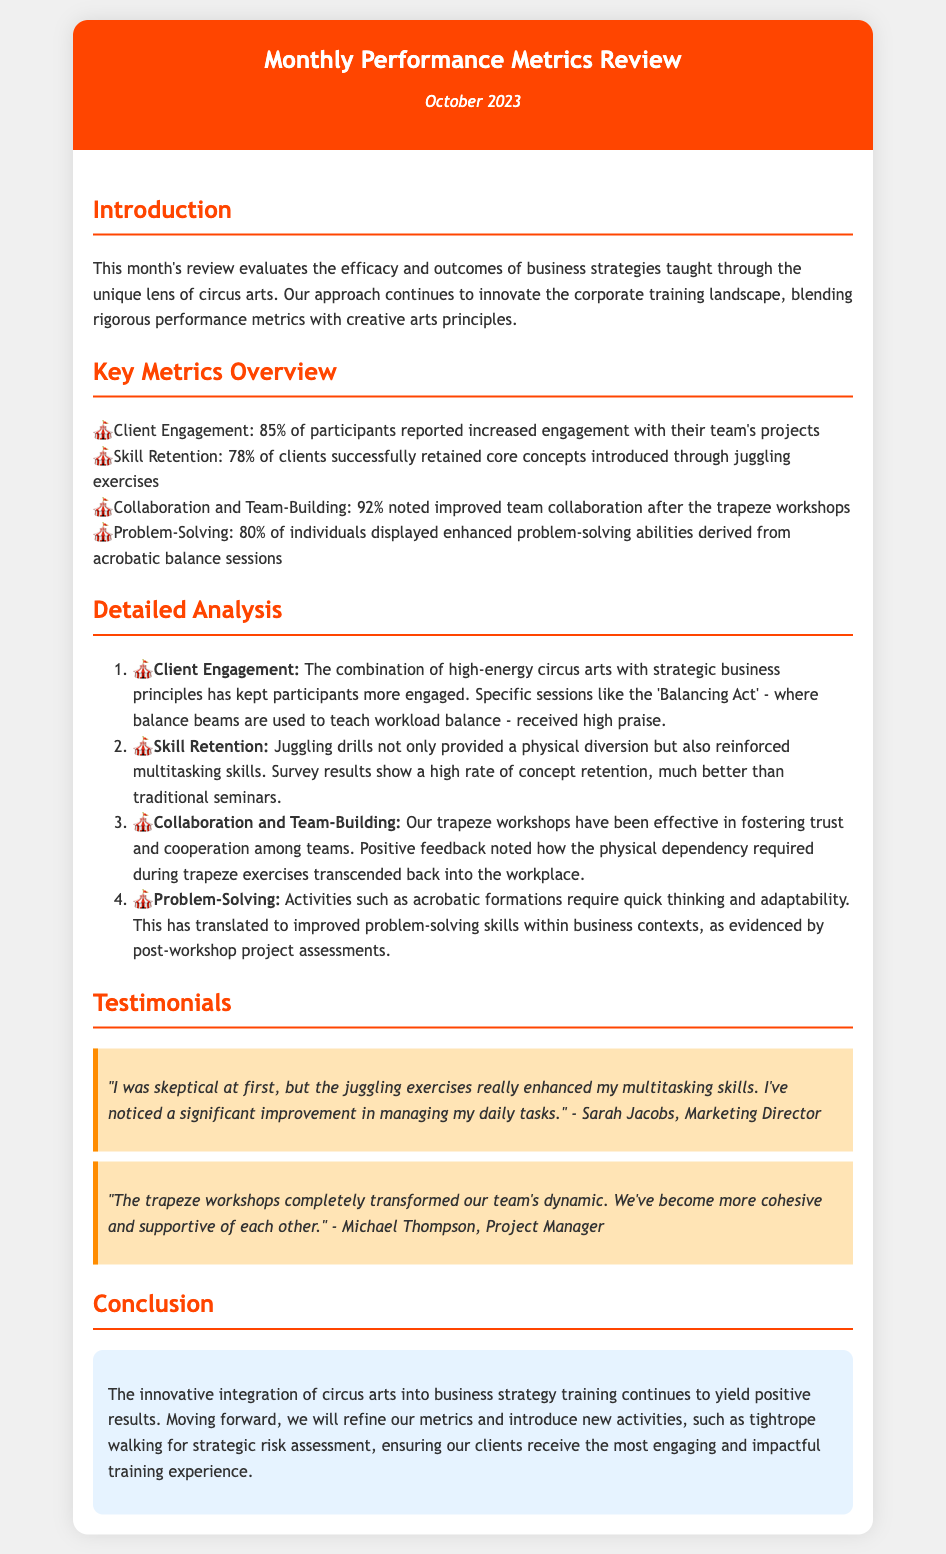What is the client engagement percentage? The document states that 85% of participants reported increased engagement with their team's projects.
Answer: 85% What skill retention rate is noted in the review? The review notes that 78% of clients successfully retained core concepts introduced through juggling exercises.
Answer: 78% Which workshop improved collaboration and team-building? The document indicates that trapeze workshops were effective in fostering trust and cooperation among teams.
Answer: Trapeze workshops What is one positive outcome of the acrobatic balance sessions? The acrobatic balance sessions led to enhanced problem-solving abilities for 80% of individuals.
Answer: Enhanced problem-solving What feedback did Sarah Jacobs provide? Sarah Jacobs remarked that juggling exercises enhanced her multitasking skills and improved daily task management.
Answer: Enhanced multitasking skills What new activity is planned for strategic risk assessment? The document mentions that tightrope walking will be introduced for strategic risk assessment.
Answer: Tightrope walking What does the introduction highlight about the training approach? The introduction highlights that the approach blends rigorous performance metrics with creative arts principles.
Answer: Blends rigorous performance metrics with creative arts principles What physical activity is used to teach workload balance? The 'Balancing Act' session uses balance beams to teach workload balance.
Answer: Balance beams 